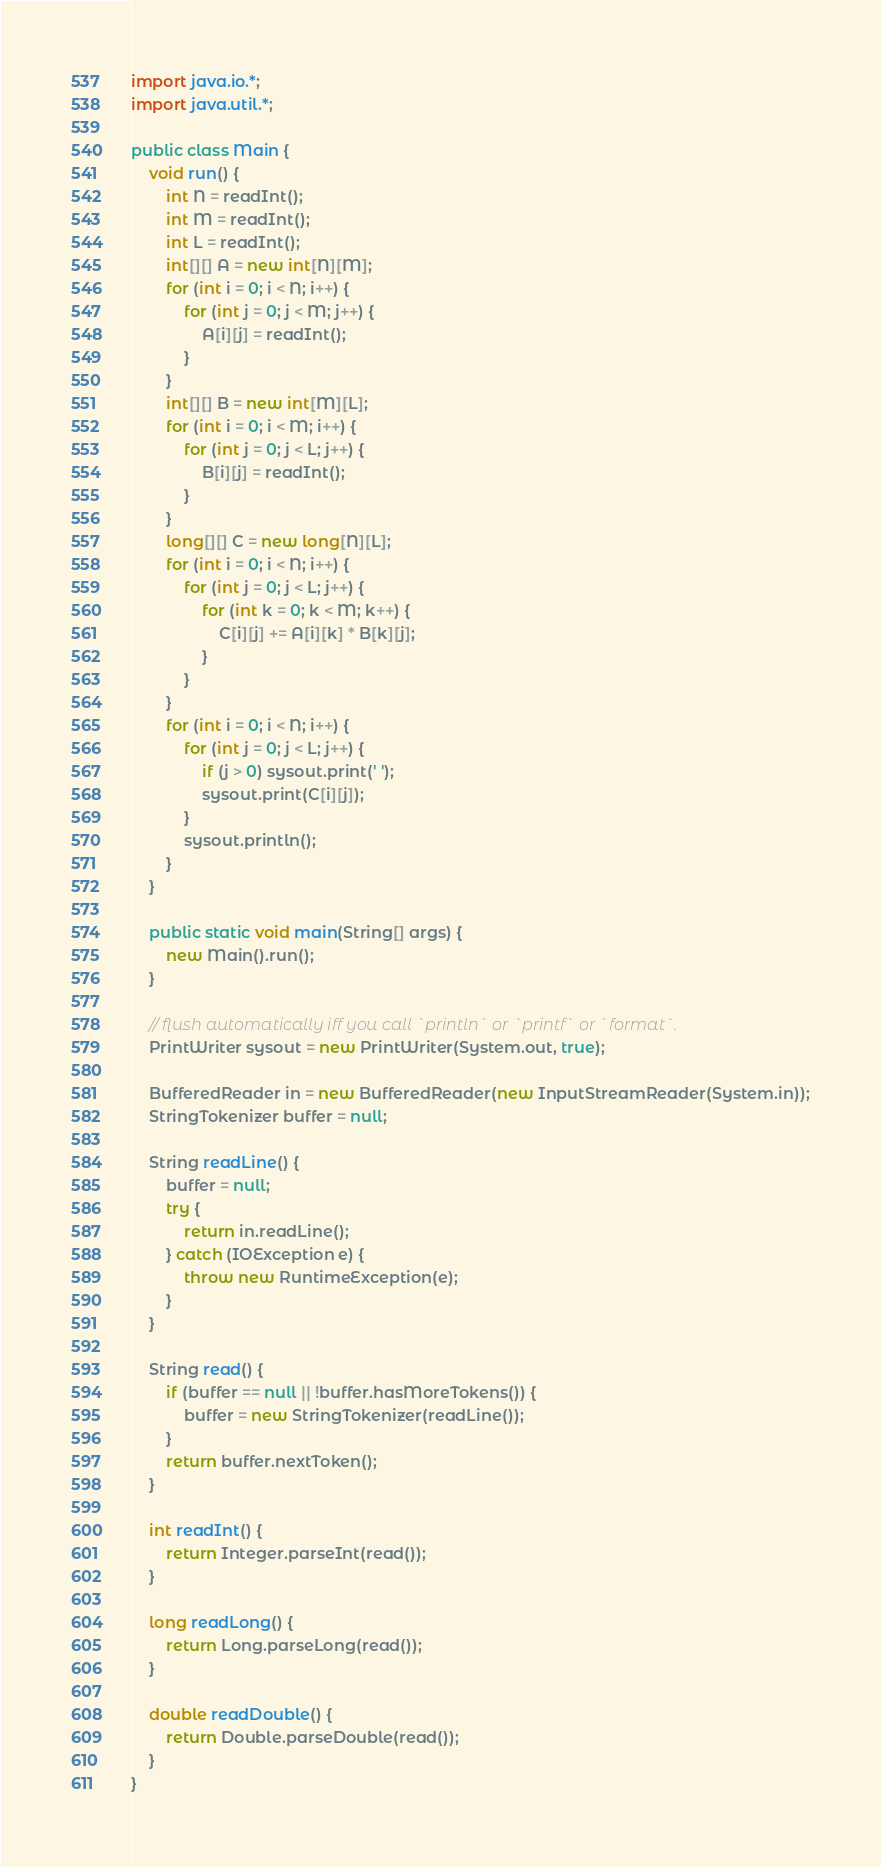Convert code to text. <code><loc_0><loc_0><loc_500><loc_500><_Java_>import java.io.*;
import java.util.*;

public class Main {
    void run() {
        int N = readInt();
        int M = readInt();
        int L = readInt();
        int[][] A = new int[N][M];
        for (int i = 0; i < N; i++) {
            for (int j = 0; j < M; j++) {
                A[i][j] = readInt();
            }
        }
        int[][] B = new int[M][L];
        for (int i = 0; i < M; i++) {
            for (int j = 0; j < L; j++) {
                B[i][j] = readInt();
            }
        }
        long[][] C = new long[N][L];
        for (int i = 0; i < N; i++) {
            for (int j = 0; j < L; j++) {
                for (int k = 0; k < M; k++) {
                    C[i][j] += A[i][k] * B[k][j];
                }
            }
        }
        for (int i = 0; i < N; i++) {
            for (int j = 0; j < L; j++) {
                if (j > 0) sysout.print(' ');
                sysout.print(C[i][j]);
            }
            sysout.println();
        }
    }

    public static void main(String[] args) {
        new Main().run();
    }

    // flush automatically iff you call `println` or `printf` or `format`.
    PrintWriter sysout = new PrintWriter(System.out, true);

    BufferedReader in = new BufferedReader(new InputStreamReader(System.in));
    StringTokenizer buffer = null;

    String readLine() {
        buffer = null;
        try {
            return in.readLine();
        } catch (IOException e) {
            throw new RuntimeException(e);
        }
    }

    String read() {
        if (buffer == null || !buffer.hasMoreTokens()) {
            buffer = new StringTokenizer(readLine());
        }
        return buffer.nextToken();
    }

    int readInt() {
        return Integer.parseInt(read());
    }

    long readLong() {
        return Long.parseLong(read());
    }

    double readDouble() {
        return Double.parseDouble(read());
    }
}</code> 